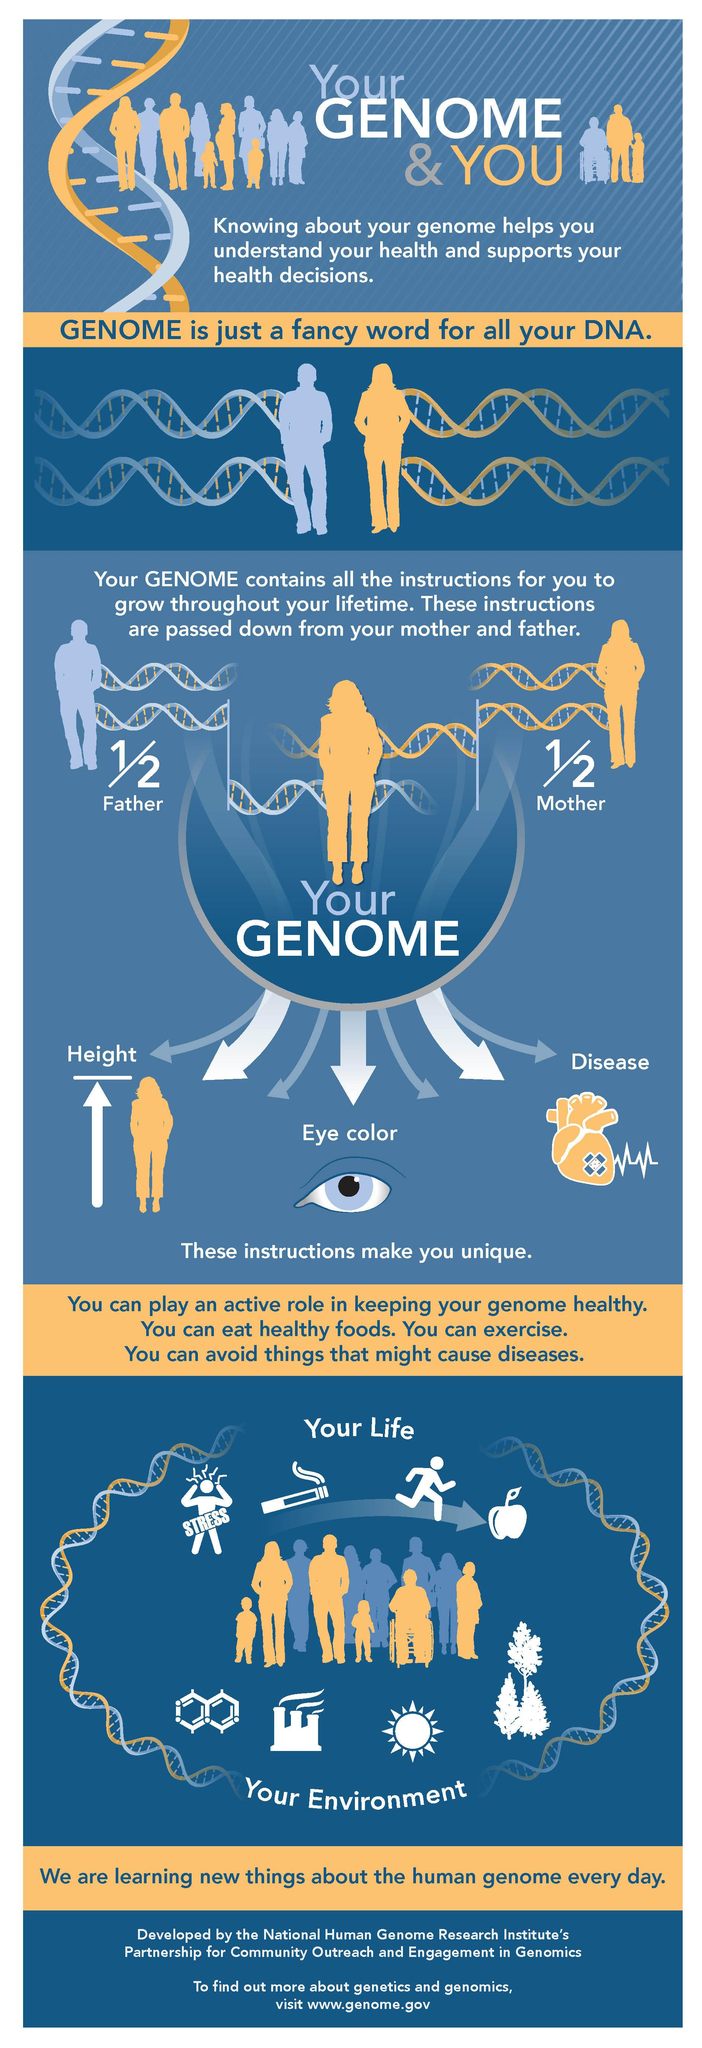Identify some key points in this picture. The infographic primarily features the use of blue, yellow, and white colors. 